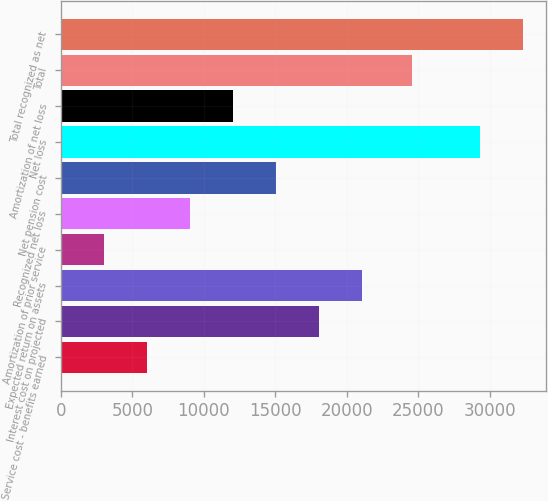<chart> <loc_0><loc_0><loc_500><loc_500><bar_chart><fcel>Service cost - benefits earned<fcel>Interest cost on projected<fcel>Expected return on assets<fcel>Amortization of prior service<fcel>Recognized net loss<fcel>Net pension cost<fcel>Net loss<fcel>Amortization of net loss<fcel>Total<fcel>Total recognized as net<nl><fcel>6032.4<fcel>18083.2<fcel>21095.9<fcel>3019.7<fcel>9045.1<fcel>15070.5<fcel>29297<fcel>12057.8<fcel>24596<fcel>32309.7<nl></chart> 